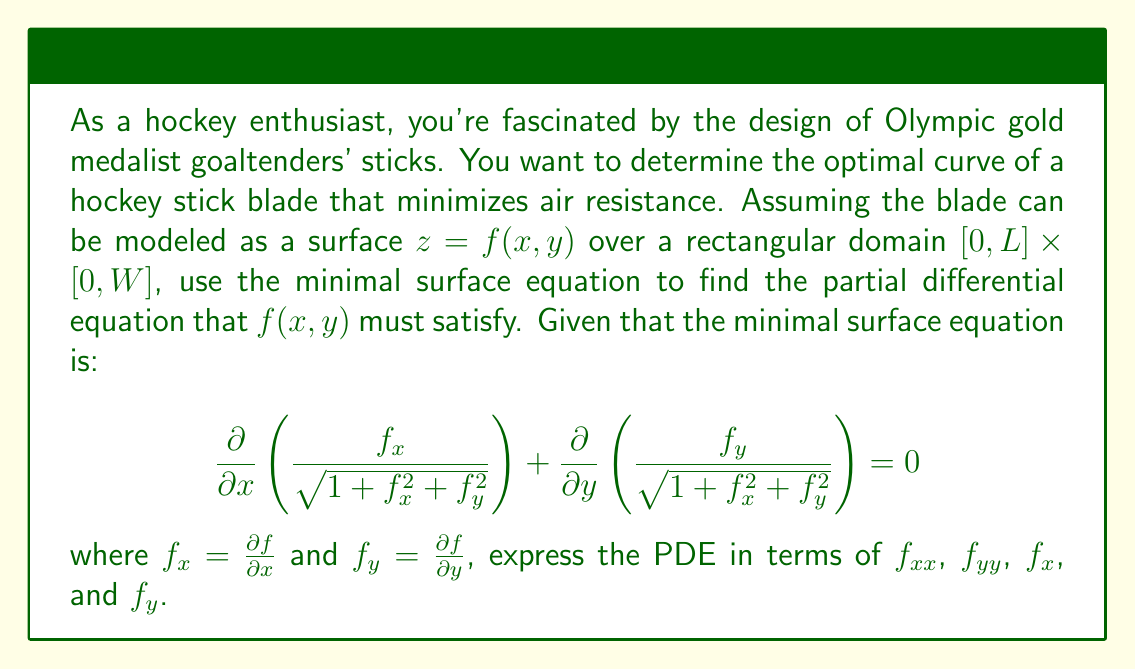Could you help me with this problem? To solve this problem, we need to expand the minimal surface equation and simplify it. Let's break it down step by step:

1) First, let's expand the partial derivatives:

   $$\frac{\partial}{\partial x}\left(\frac{f_x}{\sqrt{1+f_x^2+f_y^2}}\right) + \frac{\partial}{\partial y}\left(\frac{f_y}{\sqrt{1+f_x^2+f_y^2}}\right) = 0$$

2) Let's focus on the first term. Using the quotient rule:

   $$\frac{\partial}{\partial x}\left(\frac{f_x}{\sqrt{1+f_x^2+f_y^2}}\right) = \frac{f_{xx}\sqrt{1+f_x^2+f_y^2} - f_x\frac{1}{2\sqrt{1+f_x^2+f_y^2}}(2f_xf_{xx})}{1+f_x^2+f_y^2}$$

3) Similarly for the second term:

   $$\frac{\partial}{\partial y}\left(\frac{f_y}{\sqrt{1+f_x^2+f_y^2}}\right) = \frac{f_{yy}\sqrt{1+f_x^2+f_y^2} - f_y\frac{1}{2\sqrt{1+f_x^2+f_y^2}}(2f_yf_{yy})}{1+f_x^2+f_y^2}$$

4) Now, let's add these terms and set them equal to zero:

   $$\frac{f_{xx}\sqrt{1+f_x^2+f_y^2} - f_x\frac{f_xf_{xx}}{\sqrt{1+f_x^2+f_y^2}}}{1+f_x^2+f_y^2} + \frac{f_{yy}\sqrt{1+f_x^2+f_y^2} - f_y\frac{f_yf_{yy}}{\sqrt{1+f_x^2+f_y^2}}}{1+f_x^2+f_y^2} = 0$$

5) Multiply both sides by $(1+f_x^2+f_y^2)^{3/2}$:

   $$(1+f_x^2+f_y^2)f_{xx} - f_x^2f_{xx} + (1+f_x^2+f_y^2)f_{yy} - f_y^2f_{yy} = 0$$

6) Simplify:

   $$(1+f_y^2)f_{xx} - 2f_xf_yf_{xy} + (1+f_x^2)f_{yy} = 0$$

This is the final form of the PDE that $f(x,y)$ must satisfy to minimize the surface area, which in turn minimizes air resistance for the hockey stick blade.
Answer: The optimal curve of the hockey stick blade, represented by $f(x,y)$, must satisfy the following partial differential equation:

$$(1+f_y^2)f_{xx} - 2f_xf_yf_{xy} + (1+f_x^2)f_{yy} = 0$$

where $f_x = \frac{\partial f}{\partial x}$, $f_y = \frac{\partial f}{\partial y}$, $f_{xx} = \frac{\partial^2 f}{\partial x^2}$, $f_{yy} = \frac{\partial^2 f}{\partial y^2}$, and $f_{xy} = \frac{\partial^2 f}{\partial x \partial y}$. 